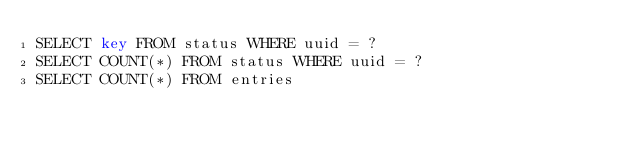Convert code to text. <code><loc_0><loc_0><loc_500><loc_500><_SQL_>SELECT key FROM status WHERE uuid = ?
SELECT COUNT(*) FROM status WHERE uuid = ?
SELECT COUNT(*) FROM entries </code> 